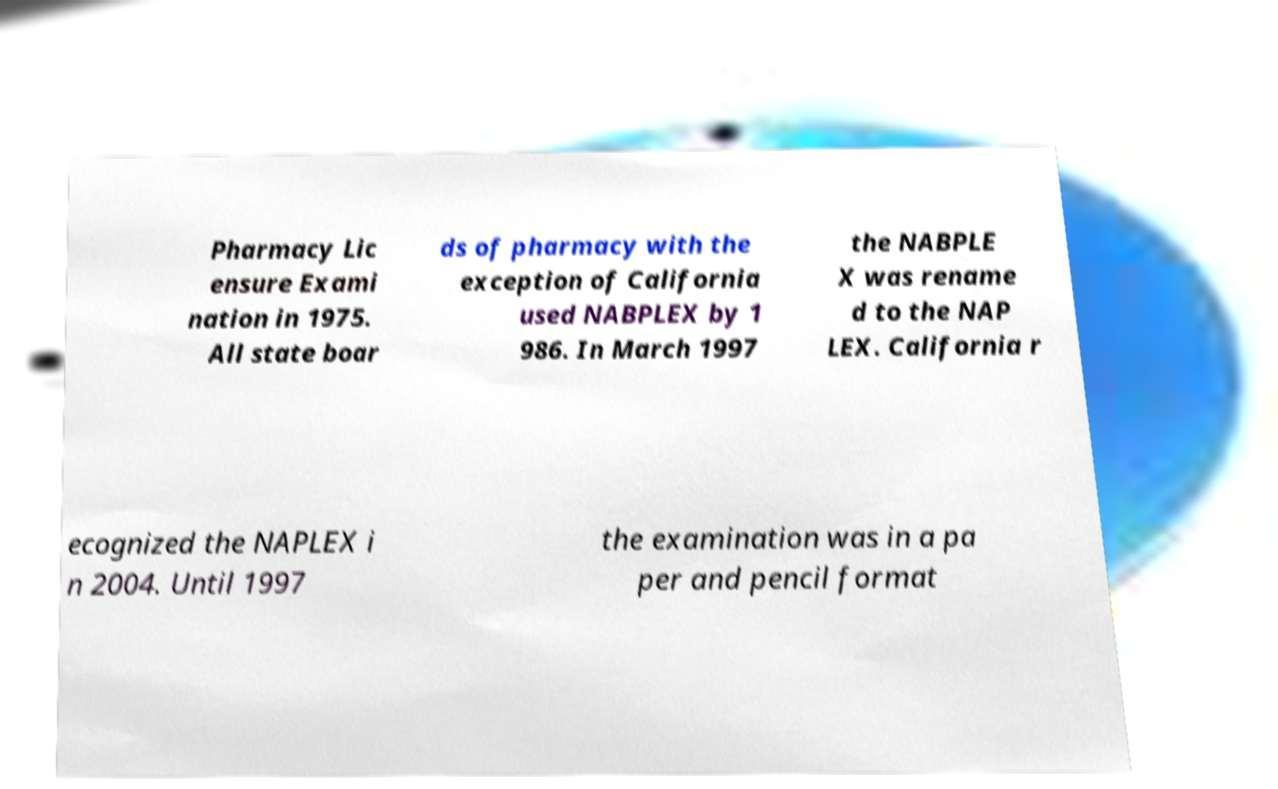Please read and relay the text visible in this image. What does it say? Pharmacy Lic ensure Exami nation in 1975. All state boar ds of pharmacy with the exception of California used NABPLEX by 1 986. In March 1997 the NABPLE X was rename d to the NAP LEX. California r ecognized the NAPLEX i n 2004. Until 1997 the examination was in a pa per and pencil format 